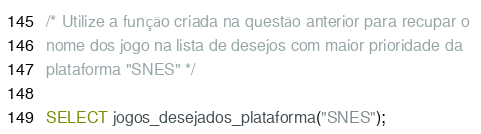Convert code to text. <code><loc_0><loc_0><loc_500><loc_500><_SQL_>/* Utilize a função criada na questão anterior para recupar o 
nome dos jogo na lista de desejos com maior prioridade da 
plataforma "SNES" */

SELECT jogos_desejados_plataforma("SNES");</code> 